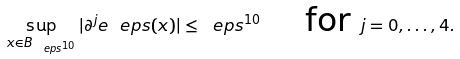<formula> <loc_0><loc_0><loc_500><loc_500>\sup _ { x \in B _ { \ e p s ^ { 1 0 } } } | \partial ^ { j } e _ { \ } e p s ( x ) | \leq \ e p s ^ { 1 0 } \quad \text { for } j = 0 , \dots , 4 .</formula> 